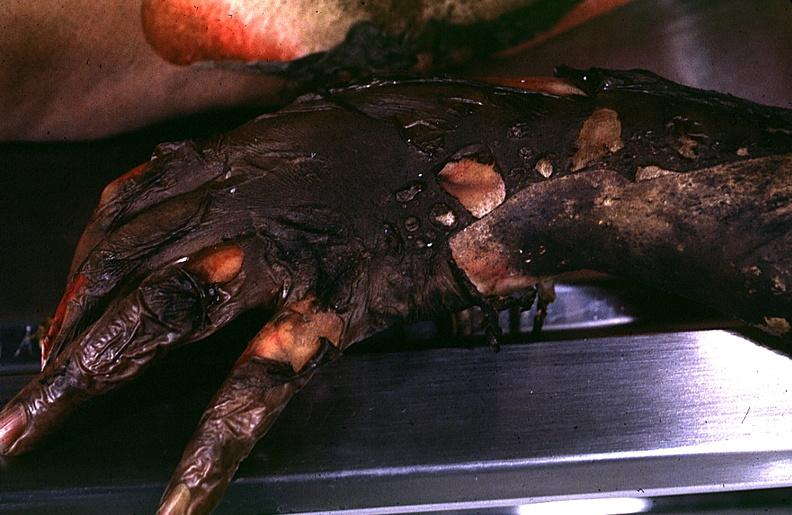do thermal burn?
Answer the question using a single word or phrase. Yes 